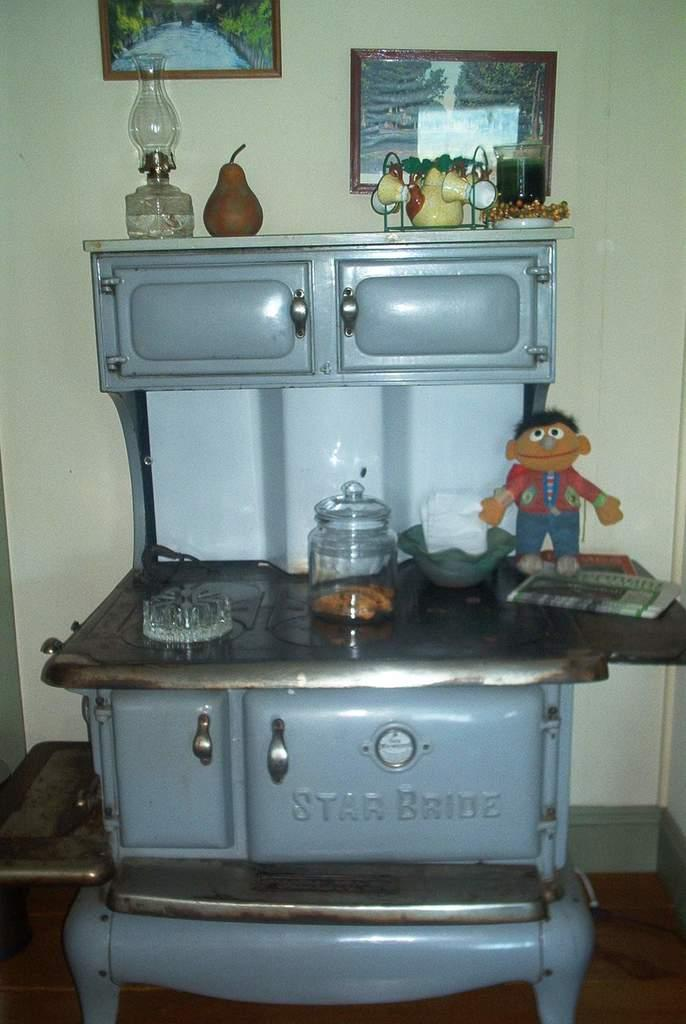<image>
Present a compact description of the photo's key features. A Star Bride stove sits in the kitchen with decorations on it. 